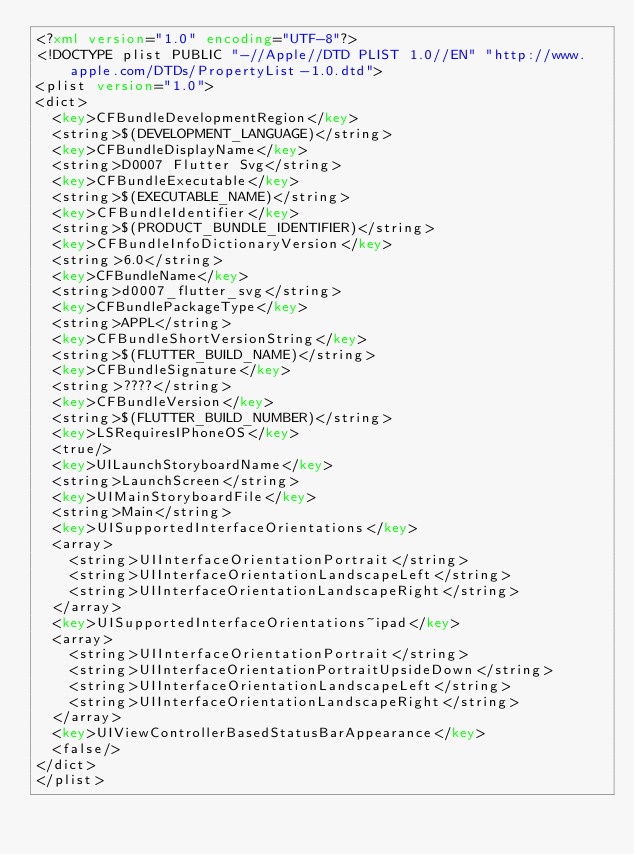Convert code to text. <code><loc_0><loc_0><loc_500><loc_500><_XML_><?xml version="1.0" encoding="UTF-8"?>
<!DOCTYPE plist PUBLIC "-//Apple//DTD PLIST 1.0//EN" "http://www.apple.com/DTDs/PropertyList-1.0.dtd">
<plist version="1.0">
<dict>
	<key>CFBundleDevelopmentRegion</key>
	<string>$(DEVELOPMENT_LANGUAGE)</string>
	<key>CFBundleDisplayName</key>
	<string>D0007 Flutter Svg</string>
	<key>CFBundleExecutable</key>
	<string>$(EXECUTABLE_NAME)</string>
	<key>CFBundleIdentifier</key>
	<string>$(PRODUCT_BUNDLE_IDENTIFIER)</string>
	<key>CFBundleInfoDictionaryVersion</key>
	<string>6.0</string>
	<key>CFBundleName</key>
	<string>d0007_flutter_svg</string>
	<key>CFBundlePackageType</key>
	<string>APPL</string>
	<key>CFBundleShortVersionString</key>
	<string>$(FLUTTER_BUILD_NAME)</string>
	<key>CFBundleSignature</key>
	<string>????</string>
	<key>CFBundleVersion</key>
	<string>$(FLUTTER_BUILD_NUMBER)</string>
	<key>LSRequiresIPhoneOS</key>
	<true/>
	<key>UILaunchStoryboardName</key>
	<string>LaunchScreen</string>
	<key>UIMainStoryboardFile</key>
	<string>Main</string>
	<key>UISupportedInterfaceOrientations</key>
	<array>
		<string>UIInterfaceOrientationPortrait</string>
		<string>UIInterfaceOrientationLandscapeLeft</string>
		<string>UIInterfaceOrientationLandscapeRight</string>
	</array>
	<key>UISupportedInterfaceOrientations~ipad</key>
	<array>
		<string>UIInterfaceOrientationPortrait</string>
		<string>UIInterfaceOrientationPortraitUpsideDown</string>
		<string>UIInterfaceOrientationLandscapeLeft</string>
		<string>UIInterfaceOrientationLandscapeRight</string>
	</array>
	<key>UIViewControllerBasedStatusBarAppearance</key>
	<false/>
</dict>
</plist>
</code> 